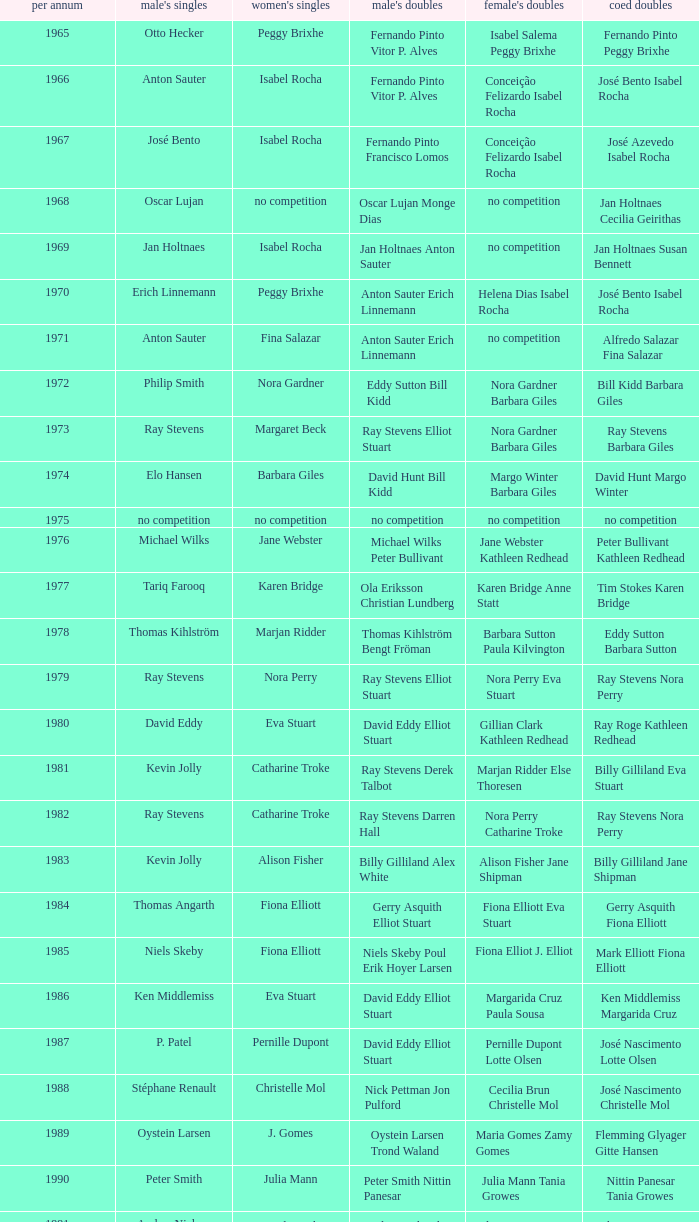Which women's doubles happened after 1987 and a women's single of astrid van der knaap? Elena Denisova Marina Yakusheva. 